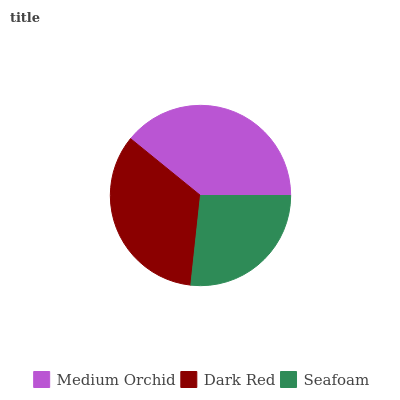Is Seafoam the minimum?
Answer yes or no. Yes. Is Medium Orchid the maximum?
Answer yes or no. Yes. Is Dark Red the minimum?
Answer yes or no. No. Is Dark Red the maximum?
Answer yes or no. No. Is Medium Orchid greater than Dark Red?
Answer yes or no. Yes. Is Dark Red less than Medium Orchid?
Answer yes or no. Yes. Is Dark Red greater than Medium Orchid?
Answer yes or no. No. Is Medium Orchid less than Dark Red?
Answer yes or no. No. Is Dark Red the high median?
Answer yes or no. Yes. Is Dark Red the low median?
Answer yes or no. Yes. Is Seafoam the high median?
Answer yes or no. No. Is Seafoam the low median?
Answer yes or no. No. 